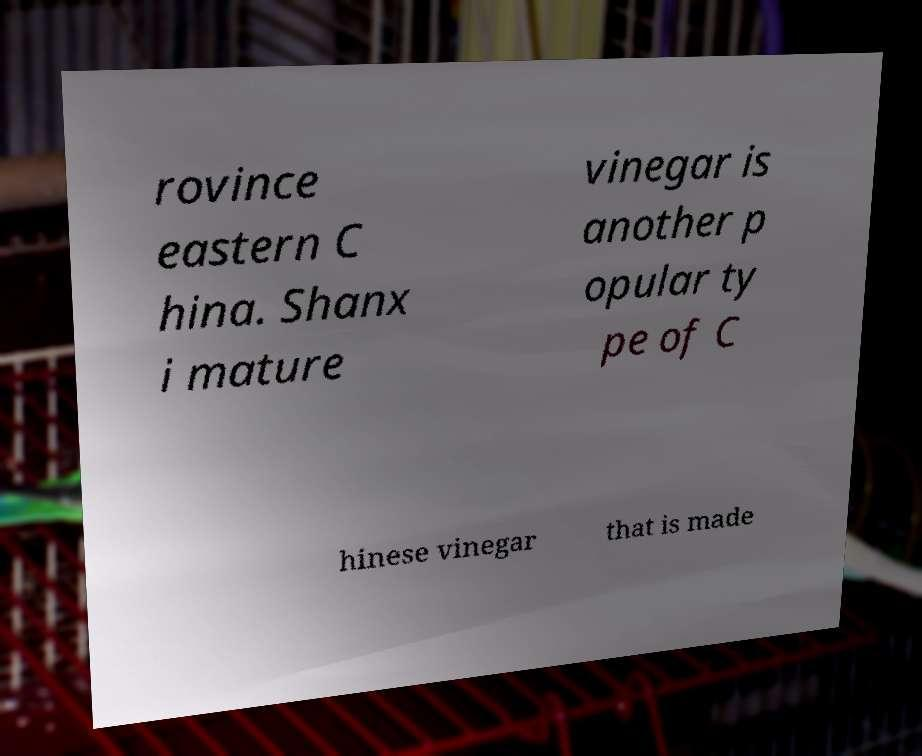Please identify and transcribe the text found in this image. rovince eastern C hina. Shanx i mature vinegar is another p opular ty pe of C hinese vinegar that is made 